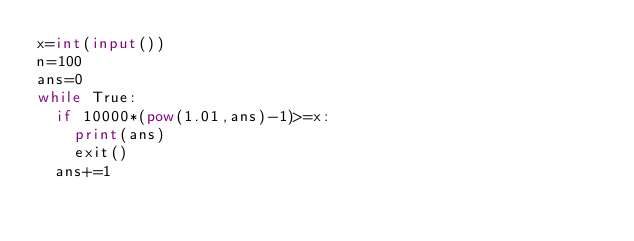Convert code to text. <code><loc_0><loc_0><loc_500><loc_500><_Python_>x=int(input())
n=100
ans=0
while True:
  if 10000*(pow(1.01,ans)-1)>=x:
    print(ans)
    exit()
  ans+=1</code> 